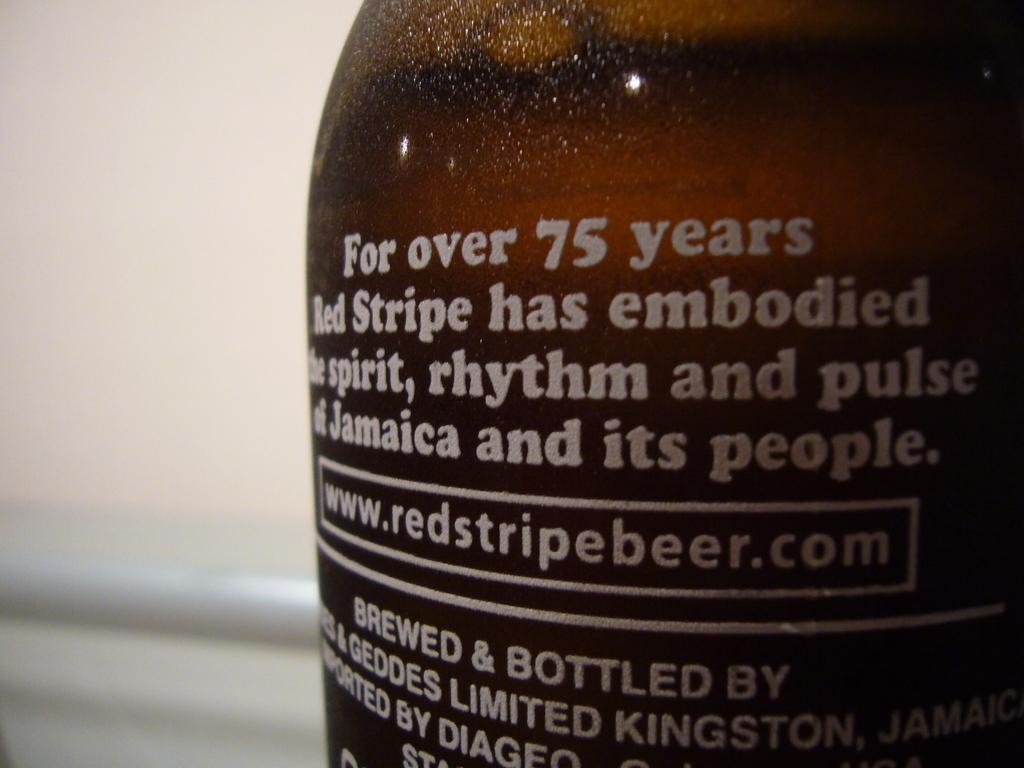Provide a one-sentence caption for the provided image. A brown bottle with a description and a website that is www.redstripedbeer.com is on it. 